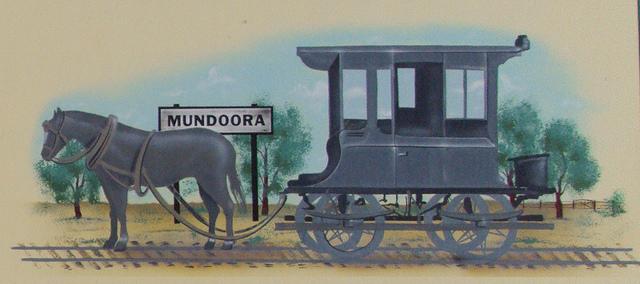Is the horse harnessed?
Give a very brief answer. Yes. Is this a real picture?
Quick response, please. No. What is the name of the town on the sign?
Be succinct. Mundoora. 